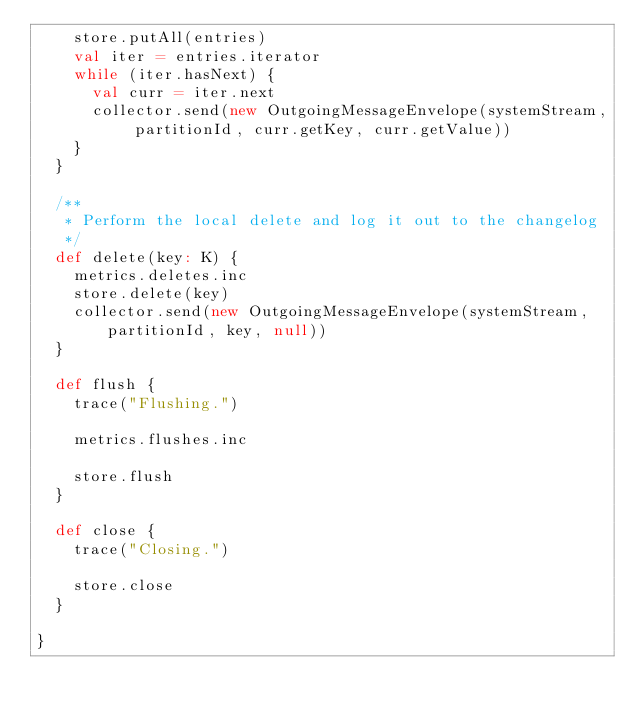Convert code to text. <code><loc_0><loc_0><loc_500><loc_500><_Scala_>    store.putAll(entries)
    val iter = entries.iterator
    while (iter.hasNext) {
      val curr = iter.next
      collector.send(new OutgoingMessageEnvelope(systemStream, partitionId, curr.getKey, curr.getValue))
    }
  }

  /**
   * Perform the local delete and log it out to the changelog
   */
  def delete(key: K) {
    metrics.deletes.inc
    store.delete(key)
    collector.send(new OutgoingMessageEnvelope(systemStream, partitionId, key, null))
  }

  def flush {
    trace("Flushing.")

    metrics.flushes.inc

    store.flush
  }

  def close {
    trace("Closing.")

    store.close
  }

}
</code> 